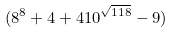<formula> <loc_0><loc_0><loc_500><loc_500>( 8 ^ { 8 } + 4 + 4 1 0 ^ { \sqrt { 1 1 8 } } - 9 )</formula> 